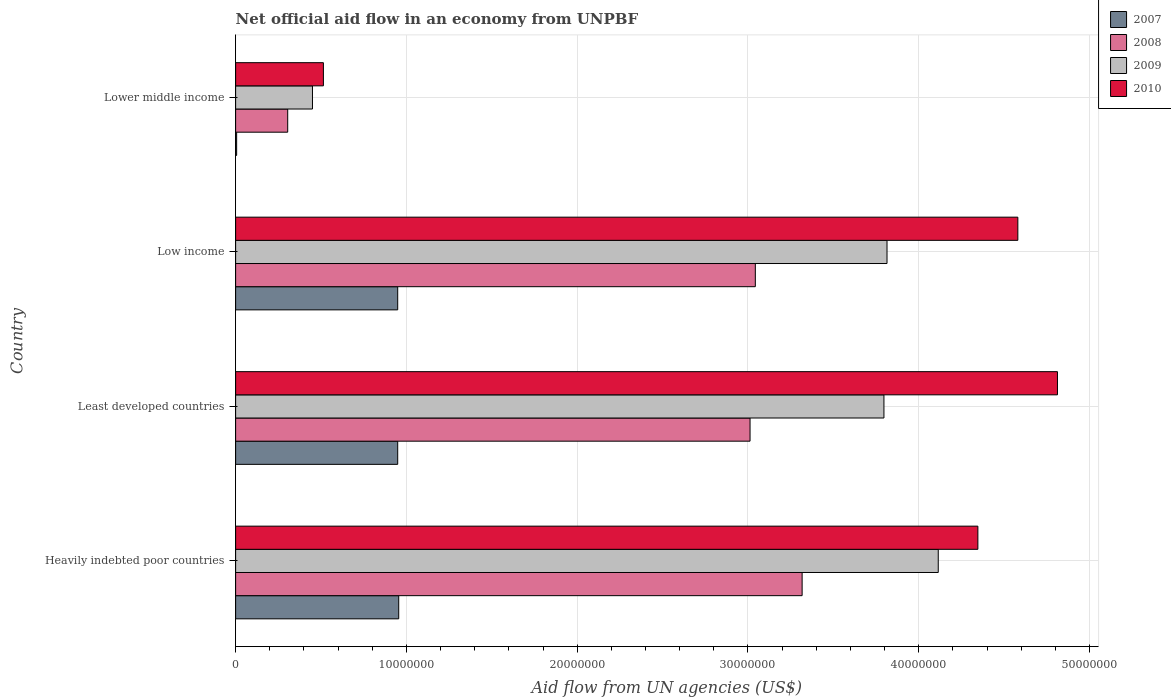How many groups of bars are there?
Keep it short and to the point. 4. Are the number of bars per tick equal to the number of legend labels?
Give a very brief answer. Yes. Are the number of bars on each tick of the Y-axis equal?
Give a very brief answer. Yes. How many bars are there on the 2nd tick from the top?
Your response must be concise. 4. How many bars are there on the 1st tick from the bottom?
Make the answer very short. 4. What is the label of the 3rd group of bars from the top?
Give a very brief answer. Least developed countries. What is the net official aid flow in 2008 in Lower middle income?
Your response must be concise. 3.05e+06. Across all countries, what is the maximum net official aid flow in 2010?
Give a very brief answer. 4.81e+07. Across all countries, what is the minimum net official aid flow in 2009?
Give a very brief answer. 4.50e+06. In which country was the net official aid flow in 2009 maximum?
Ensure brevity in your answer.  Heavily indebted poor countries. In which country was the net official aid flow in 2008 minimum?
Provide a succinct answer. Lower middle income. What is the total net official aid flow in 2010 in the graph?
Your answer should be very brief. 1.43e+08. What is the difference between the net official aid flow in 2010 in Heavily indebted poor countries and that in Lower middle income?
Your response must be concise. 3.83e+07. What is the difference between the net official aid flow in 2008 in Heavily indebted poor countries and the net official aid flow in 2009 in Lower middle income?
Your response must be concise. 2.87e+07. What is the average net official aid flow in 2008 per country?
Your answer should be very brief. 2.42e+07. What is the difference between the net official aid flow in 2007 and net official aid flow in 2010 in Least developed countries?
Offer a very short reply. -3.86e+07. What is the ratio of the net official aid flow in 2007 in Least developed countries to that in Lower middle income?
Give a very brief answer. 158.17. Is the net official aid flow in 2008 in Heavily indebted poor countries less than that in Low income?
Keep it short and to the point. No. What is the difference between the highest and the lowest net official aid flow in 2009?
Keep it short and to the point. 3.66e+07. In how many countries, is the net official aid flow in 2010 greater than the average net official aid flow in 2010 taken over all countries?
Your response must be concise. 3. How many countries are there in the graph?
Ensure brevity in your answer.  4. Does the graph contain any zero values?
Ensure brevity in your answer.  No. Does the graph contain grids?
Your response must be concise. Yes. Where does the legend appear in the graph?
Offer a very short reply. Top right. How many legend labels are there?
Make the answer very short. 4. What is the title of the graph?
Offer a terse response. Net official aid flow in an economy from UNPBF. What is the label or title of the X-axis?
Your answer should be very brief. Aid flow from UN agencies (US$). What is the Aid flow from UN agencies (US$) in 2007 in Heavily indebted poor countries?
Offer a terse response. 9.55e+06. What is the Aid flow from UN agencies (US$) of 2008 in Heavily indebted poor countries?
Ensure brevity in your answer.  3.32e+07. What is the Aid flow from UN agencies (US$) of 2009 in Heavily indebted poor countries?
Give a very brief answer. 4.11e+07. What is the Aid flow from UN agencies (US$) in 2010 in Heavily indebted poor countries?
Provide a succinct answer. 4.35e+07. What is the Aid flow from UN agencies (US$) of 2007 in Least developed countries?
Keep it short and to the point. 9.49e+06. What is the Aid flow from UN agencies (US$) of 2008 in Least developed countries?
Give a very brief answer. 3.01e+07. What is the Aid flow from UN agencies (US$) of 2009 in Least developed countries?
Provide a succinct answer. 3.80e+07. What is the Aid flow from UN agencies (US$) in 2010 in Least developed countries?
Ensure brevity in your answer.  4.81e+07. What is the Aid flow from UN agencies (US$) in 2007 in Low income?
Ensure brevity in your answer.  9.49e+06. What is the Aid flow from UN agencies (US$) of 2008 in Low income?
Give a very brief answer. 3.04e+07. What is the Aid flow from UN agencies (US$) in 2009 in Low income?
Offer a very short reply. 3.81e+07. What is the Aid flow from UN agencies (US$) of 2010 in Low income?
Provide a succinct answer. 4.58e+07. What is the Aid flow from UN agencies (US$) in 2008 in Lower middle income?
Provide a succinct answer. 3.05e+06. What is the Aid flow from UN agencies (US$) in 2009 in Lower middle income?
Keep it short and to the point. 4.50e+06. What is the Aid flow from UN agencies (US$) in 2010 in Lower middle income?
Provide a succinct answer. 5.14e+06. Across all countries, what is the maximum Aid flow from UN agencies (US$) in 2007?
Your answer should be compact. 9.55e+06. Across all countries, what is the maximum Aid flow from UN agencies (US$) in 2008?
Your response must be concise. 3.32e+07. Across all countries, what is the maximum Aid flow from UN agencies (US$) in 2009?
Make the answer very short. 4.11e+07. Across all countries, what is the maximum Aid flow from UN agencies (US$) in 2010?
Provide a succinct answer. 4.81e+07. Across all countries, what is the minimum Aid flow from UN agencies (US$) of 2008?
Your answer should be compact. 3.05e+06. Across all countries, what is the minimum Aid flow from UN agencies (US$) in 2009?
Provide a short and direct response. 4.50e+06. Across all countries, what is the minimum Aid flow from UN agencies (US$) in 2010?
Make the answer very short. 5.14e+06. What is the total Aid flow from UN agencies (US$) of 2007 in the graph?
Make the answer very short. 2.86e+07. What is the total Aid flow from UN agencies (US$) of 2008 in the graph?
Make the answer very short. 9.68e+07. What is the total Aid flow from UN agencies (US$) in 2009 in the graph?
Provide a succinct answer. 1.22e+08. What is the total Aid flow from UN agencies (US$) in 2010 in the graph?
Offer a terse response. 1.43e+08. What is the difference between the Aid flow from UN agencies (US$) of 2007 in Heavily indebted poor countries and that in Least developed countries?
Make the answer very short. 6.00e+04. What is the difference between the Aid flow from UN agencies (US$) of 2008 in Heavily indebted poor countries and that in Least developed countries?
Keep it short and to the point. 3.05e+06. What is the difference between the Aid flow from UN agencies (US$) of 2009 in Heavily indebted poor countries and that in Least developed countries?
Offer a very short reply. 3.18e+06. What is the difference between the Aid flow from UN agencies (US$) of 2010 in Heavily indebted poor countries and that in Least developed countries?
Your response must be concise. -4.66e+06. What is the difference between the Aid flow from UN agencies (US$) of 2008 in Heavily indebted poor countries and that in Low income?
Keep it short and to the point. 2.74e+06. What is the difference between the Aid flow from UN agencies (US$) of 2009 in Heavily indebted poor countries and that in Low income?
Provide a succinct answer. 3.00e+06. What is the difference between the Aid flow from UN agencies (US$) in 2010 in Heavily indebted poor countries and that in Low income?
Provide a short and direct response. -2.34e+06. What is the difference between the Aid flow from UN agencies (US$) of 2007 in Heavily indebted poor countries and that in Lower middle income?
Provide a short and direct response. 9.49e+06. What is the difference between the Aid flow from UN agencies (US$) of 2008 in Heavily indebted poor countries and that in Lower middle income?
Offer a very short reply. 3.01e+07. What is the difference between the Aid flow from UN agencies (US$) in 2009 in Heavily indebted poor countries and that in Lower middle income?
Ensure brevity in your answer.  3.66e+07. What is the difference between the Aid flow from UN agencies (US$) in 2010 in Heavily indebted poor countries and that in Lower middle income?
Provide a succinct answer. 3.83e+07. What is the difference between the Aid flow from UN agencies (US$) of 2007 in Least developed countries and that in Low income?
Provide a succinct answer. 0. What is the difference between the Aid flow from UN agencies (US$) of 2008 in Least developed countries and that in Low income?
Offer a terse response. -3.10e+05. What is the difference between the Aid flow from UN agencies (US$) of 2009 in Least developed countries and that in Low income?
Keep it short and to the point. -1.80e+05. What is the difference between the Aid flow from UN agencies (US$) of 2010 in Least developed countries and that in Low income?
Provide a short and direct response. 2.32e+06. What is the difference between the Aid flow from UN agencies (US$) in 2007 in Least developed countries and that in Lower middle income?
Offer a very short reply. 9.43e+06. What is the difference between the Aid flow from UN agencies (US$) of 2008 in Least developed countries and that in Lower middle income?
Give a very brief answer. 2.71e+07. What is the difference between the Aid flow from UN agencies (US$) in 2009 in Least developed countries and that in Lower middle income?
Your answer should be very brief. 3.35e+07. What is the difference between the Aid flow from UN agencies (US$) in 2010 in Least developed countries and that in Lower middle income?
Ensure brevity in your answer.  4.30e+07. What is the difference between the Aid flow from UN agencies (US$) in 2007 in Low income and that in Lower middle income?
Your answer should be compact. 9.43e+06. What is the difference between the Aid flow from UN agencies (US$) of 2008 in Low income and that in Lower middle income?
Offer a terse response. 2.74e+07. What is the difference between the Aid flow from UN agencies (US$) in 2009 in Low income and that in Lower middle income?
Give a very brief answer. 3.36e+07. What is the difference between the Aid flow from UN agencies (US$) of 2010 in Low income and that in Lower middle income?
Your answer should be very brief. 4.07e+07. What is the difference between the Aid flow from UN agencies (US$) of 2007 in Heavily indebted poor countries and the Aid flow from UN agencies (US$) of 2008 in Least developed countries?
Make the answer very short. -2.06e+07. What is the difference between the Aid flow from UN agencies (US$) of 2007 in Heavily indebted poor countries and the Aid flow from UN agencies (US$) of 2009 in Least developed countries?
Ensure brevity in your answer.  -2.84e+07. What is the difference between the Aid flow from UN agencies (US$) of 2007 in Heavily indebted poor countries and the Aid flow from UN agencies (US$) of 2010 in Least developed countries?
Provide a succinct answer. -3.86e+07. What is the difference between the Aid flow from UN agencies (US$) in 2008 in Heavily indebted poor countries and the Aid flow from UN agencies (US$) in 2009 in Least developed countries?
Give a very brief answer. -4.79e+06. What is the difference between the Aid flow from UN agencies (US$) in 2008 in Heavily indebted poor countries and the Aid flow from UN agencies (US$) in 2010 in Least developed countries?
Provide a short and direct response. -1.50e+07. What is the difference between the Aid flow from UN agencies (US$) in 2009 in Heavily indebted poor countries and the Aid flow from UN agencies (US$) in 2010 in Least developed countries?
Your answer should be compact. -6.98e+06. What is the difference between the Aid flow from UN agencies (US$) in 2007 in Heavily indebted poor countries and the Aid flow from UN agencies (US$) in 2008 in Low income?
Give a very brief answer. -2.09e+07. What is the difference between the Aid flow from UN agencies (US$) in 2007 in Heavily indebted poor countries and the Aid flow from UN agencies (US$) in 2009 in Low income?
Ensure brevity in your answer.  -2.86e+07. What is the difference between the Aid flow from UN agencies (US$) of 2007 in Heavily indebted poor countries and the Aid flow from UN agencies (US$) of 2010 in Low income?
Provide a short and direct response. -3.62e+07. What is the difference between the Aid flow from UN agencies (US$) in 2008 in Heavily indebted poor countries and the Aid flow from UN agencies (US$) in 2009 in Low income?
Provide a short and direct response. -4.97e+06. What is the difference between the Aid flow from UN agencies (US$) in 2008 in Heavily indebted poor countries and the Aid flow from UN agencies (US$) in 2010 in Low income?
Offer a very short reply. -1.26e+07. What is the difference between the Aid flow from UN agencies (US$) in 2009 in Heavily indebted poor countries and the Aid flow from UN agencies (US$) in 2010 in Low income?
Your answer should be compact. -4.66e+06. What is the difference between the Aid flow from UN agencies (US$) in 2007 in Heavily indebted poor countries and the Aid flow from UN agencies (US$) in 2008 in Lower middle income?
Ensure brevity in your answer.  6.50e+06. What is the difference between the Aid flow from UN agencies (US$) in 2007 in Heavily indebted poor countries and the Aid flow from UN agencies (US$) in 2009 in Lower middle income?
Provide a succinct answer. 5.05e+06. What is the difference between the Aid flow from UN agencies (US$) in 2007 in Heavily indebted poor countries and the Aid flow from UN agencies (US$) in 2010 in Lower middle income?
Provide a succinct answer. 4.41e+06. What is the difference between the Aid flow from UN agencies (US$) in 2008 in Heavily indebted poor countries and the Aid flow from UN agencies (US$) in 2009 in Lower middle income?
Offer a terse response. 2.87e+07. What is the difference between the Aid flow from UN agencies (US$) in 2008 in Heavily indebted poor countries and the Aid flow from UN agencies (US$) in 2010 in Lower middle income?
Ensure brevity in your answer.  2.80e+07. What is the difference between the Aid flow from UN agencies (US$) in 2009 in Heavily indebted poor countries and the Aid flow from UN agencies (US$) in 2010 in Lower middle income?
Your response must be concise. 3.60e+07. What is the difference between the Aid flow from UN agencies (US$) of 2007 in Least developed countries and the Aid flow from UN agencies (US$) of 2008 in Low income?
Make the answer very short. -2.09e+07. What is the difference between the Aid flow from UN agencies (US$) in 2007 in Least developed countries and the Aid flow from UN agencies (US$) in 2009 in Low income?
Ensure brevity in your answer.  -2.86e+07. What is the difference between the Aid flow from UN agencies (US$) in 2007 in Least developed countries and the Aid flow from UN agencies (US$) in 2010 in Low income?
Ensure brevity in your answer.  -3.63e+07. What is the difference between the Aid flow from UN agencies (US$) in 2008 in Least developed countries and the Aid flow from UN agencies (US$) in 2009 in Low income?
Make the answer very short. -8.02e+06. What is the difference between the Aid flow from UN agencies (US$) in 2008 in Least developed countries and the Aid flow from UN agencies (US$) in 2010 in Low income?
Offer a terse response. -1.57e+07. What is the difference between the Aid flow from UN agencies (US$) of 2009 in Least developed countries and the Aid flow from UN agencies (US$) of 2010 in Low income?
Provide a succinct answer. -7.84e+06. What is the difference between the Aid flow from UN agencies (US$) in 2007 in Least developed countries and the Aid flow from UN agencies (US$) in 2008 in Lower middle income?
Ensure brevity in your answer.  6.44e+06. What is the difference between the Aid flow from UN agencies (US$) in 2007 in Least developed countries and the Aid flow from UN agencies (US$) in 2009 in Lower middle income?
Keep it short and to the point. 4.99e+06. What is the difference between the Aid flow from UN agencies (US$) of 2007 in Least developed countries and the Aid flow from UN agencies (US$) of 2010 in Lower middle income?
Offer a very short reply. 4.35e+06. What is the difference between the Aid flow from UN agencies (US$) in 2008 in Least developed countries and the Aid flow from UN agencies (US$) in 2009 in Lower middle income?
Keep it short and to the point. 2.56e+07. What is the difference between the Aid flow from UN agencies (US$) of 2008 in Least developed countries and the Aid flow from UN agencies (US$) of 2010 in Lower middle income?
Make the answer very short. 2.50e+07. What is the difference between the Aid flow from UN agencies (US$) in 2009 in Least developed countries and the Aid flow from UN agencies (US$) in 2010 in Lower middle income?
Offer a terse response. 3.28e+07. What is the difference between the Aid flow from UN agencies (US$) in 2007 in Low income and the Aid flow from UN agencies (US$) in 2008 in Lower middle income?
Your response must be concise. 6.44e+06. What is the difference between the Aid flow from UN agencies (US$) of 2007 in Low income and the Aid flow from UN agencies (US$) of 2009 in Lower middle income?
Keep it short and to the point. 4.99e+06. What is the difference between the Aid flow from UN agencies (US$) of 2007 in Low income and the Aid flow from UN agencies (US$) of 2010 in Lower middle income?
Make the answer very short. 4.35e+06. What is the difference between the Aid flow from UN agencies (US$) in 2008 in Low income and the Aid flow from UN agencies (US$) in 2009 in Lower middle income?
Your answer should be compact. 2.59e+07. What is the difference between the Aid flow from UN agencies (US$) in 2008 in Low income and the Aid flow from UN agencies (US$) in 2010 in Lower middle income?
Provide a short and direct response. 2.53e+07. What is the difference between the Aid flow from UN agencies (US$) in 2009 in Low income and the Aid flow from UN agencies (US$) in 2010 in Lower middle income?
Your answer should be very brief. 3.30e+07. What is the average Aid flow from UN agencies (US$) of 2007 per country?
Make the answer very short. 7.15e+06. What is the average Aid flow from UN agencies (US$) in 2008 per country?
Give a very brief answer. 2.42e+07. What is the average Aid flow from UN agencies (US$) of 2009 per country?
Your answer should be compact. 3.04e+07. What is the average Aid flow from UN agencies (US$) of 2010 per country?
Provide a succinct answer. 3.56e+07. What is the difference between the Aid flow from UN agencies (US$) in 2007 and Aid flow from UN agencies (US$) in 2008 in Heavily indebted poor countries?
Make the answer very short. -2.36e+07. What is the difference between the Aid flow from UN agencies (US$) in 2007 and Aid flow from UN agencies (US$) in 2009 in Heavily indebted poor countries?
Ensure brevity in your answer.  -3.16e+07. What is the difference between the Aid flow from UN agencies (US$) in 2007 and Aid flow from UN agencies (US$) in 2010 in Heavily indebted poor countries?
Provide a succinct answer. -3.39e+07. What is the difference between the Aid flow from UN agencies (US$) in 2008 and Aid flow from UN agencies (US$) in 2009 in Heavily indebted poor countries?
Your answer should be very brief. -7.97e+06. What is the difference between the Aid flow from UN agencies (US$) in 2008 and Aid flow from UN agencies (US$) in 2010 in Heavily indebted poor countries?
Your response must be concise. -1.03e+07. What is the difference between the Aid flow from UN agencies (US$) of 2009 and Aid flow from UN agencies (US$) of 2010 in Heavily indebted poor countries?
Give a very brief answer. -2.32e+06. What is the difference between the Aid flow from UN agencies (US$) in 2007 and Aid flow from UN agencies (US$) in 2008 in Least developed countries?
Provide a succinct answer. -2.06e+07. What is the difference between the Aid flow from UN agencies (US$) of 2007 and Aid flow from UN agencies (US$) of 2009 in Least developed countries?
Give a very brief answer. -2.85e+07. What is the difference between the Aid flow from UN agencies (US$) of 2007 and Aid flow from UN agencies (US$) of 2010 in Least developed countries?
Your answer should be very brief. -3.86e+07. What is the difference between the Aid flow from UN agencies (US$) of 2008 and Aid flow from UN agencies (US$) of 2009 in Least developed countries?
Offer a very short reply. -7.84e+06. What is the difference between the Aid flow from UN agencies (US$) in 2008 and Aid flow from UN agencies (US$) in 2010 in Least developed countries?
Provide a short and direct response. -1.80e+07. What is the difference between the Aid flow from UN agencies (US$) in 2009 and Aid flow from UN agencies (US$) in 2010 in Least developed countries?
Offer a terse response. -1.02e+07. What is the difference between the Aid flow from UN agencies (US$) in 2007 and Aid flow from UN agencies (US$) in 2008 in Low income?
Keep it short and to the point. -2.09e+07. What is the difference between the Aid flow from UN agencies (US$) of 2007 and Aid flow from UN agencies (US$) of 2009 in Low income?
Give a very brief answer. -2.86e+07. What is the difference between the Aid flow from UN agencies (US$) of 2007 and Aid flow from UN agencies (US$) of 2010 in Low income?
Give a very brief answer. -3.63e+07. What is the difference between the Aid flow from UN agencies (US$) of 2008 and Aid flow from UN agencies (US$) of 2009 in Low income?
Provide a short and direct response. -7.71e+06. What is the difference between the Aid flow from UN agencies (US$) in 2008 and Aid flow from UN agencies (US$) in 2010 in Low income?
Ensure brevity in your answer.  -1.54e+07. What is the difference between the Aid flow from UN agencies (US$) in 2009 and Aid flow from UN agencies (US$) in 2010 in Low income?
Make the answer very short. -7.66e+06. What is the difference between the Aid flow from UN agencies (US$) of 2007 and Aid flow from UN agencies (US$) of 2008 in Lower middle income?
Make the answer very short. -2.99e+06. What is the difference between the Aid flow from UN agencies (US$) in 2007 and Aid flow from UN agencies (US$) in 2009 in Lower middle income?
Offer a very short reply. -4.44e+06. What is the difference between the Aid flow from UN agencies (US$) of 2007 and Aid flow from UN agencies (US$) of 2010 in Lower middle income?
Provide a short and direct response. -5.08e+06. What is the difference between the Aid flow from UN agencies (US$) in 2008 and Aid flow from UN agencies (US$) in 2009 in Lower middle income?
Provide a succinct answer. -1.45e+06. What is the difference between the Aid flow from UN agencies (US$) in 2008 and Aid flow from UN agencies (US$) in 2010 in Lower middle income?
Your answer should be very brief. -2.09e+06. What is the difference between the Aid flow from UN agencies (US$) of 2009 and Aid flow from UN agencies (US$) of 2010 in Lower middle income?
Your answer should be very brief. -6.40e+05. What is the ratio of the Aid flow from UN agencies (US$) in 2007 in Heavily indebted poor countries to that in Least developed countries?
Offer a very short reply. 1.01. What is the ratio of the Aid flow from UN agencies (US$) of 2008 in Heavily indebted poor countries to that in Least developed countries?
Offer a very short reply. 1.1. What is the ratio of the Aid flow from UN agencies (US$) of 2009 in Heavily indebted poor countries to that in Least developed countries?
Your response must be concise. 1.08. What is the ratio of the Aid flow from UN agencies (US$) of 2010 in Heavily indebted poor countries to that in Least developed countries?
Offer a terse response. 0.9. What is the ratio of the Aid flow from UN agencies (US$) of 2008 in Heavily indebted poor countries to that in Low income?
Your response must be concise. 1.09. What is the ratio of the Aid flow from UN agencies (US$) in 2009 in Heavily indebted poor countries to that in Low income?
Give a very brief answer. 1.08. What is the ratio of the Aid flow from UN agencies (US$) in 2010 in Heavily indebted poor countries to that in Low income?
Offer a very short reply. 0.95. What is the ratio of the Aid flow from UN agencies (US$) in 2007 in Heavily indebted poor countries to that in Lower middle income?
Your response must be concise. 159.17. What is the ratio of the Aid flow from UN agencies (US$) of 2008 in Heavily indebted poor countries to that in Lower middle income?
Offer a very short reply. 10.88. What is the ratio of the Aid flow from UN agencies (US$) in 2009 in Heavily indebted poor countries to that in Lower middle income?
Keep it short and to the point. 9.14. What is the ratio of the Aid flow from UN agencies (US$) in 2010 in Heavily indebted poor countries to that in Lower middle income?
Provide a short and direct response. 8.46. What is the ratio of the Aid flow from UN agencies (US$) in 2007 in Least developed countries to that in Low income?
Offer a very short reply. 1. What is the ratio of the Aid flow from UN agencies (US$) in 2009 in Least developed countries to that in Low income?
Your answer should be compact. 1. What is the ratio of the Aid flow from UN agencies (US$) in 2010 in Least developed countries to that in Low income?
Your answer should be compact. 1.05. What is the ratio of the Aid flow from UN agencies (US$) in 2007 in Least developed countries to that in Lower middle income?
Keep it short and to the point. 158.17. What is the ratio of the Aid flow from UN agencies (US$) in 2008 in Least developed countries to that in Lower middle income?
Give a very brief answer. 9.88. What is the ratio of the Aid flow from UN agencies (US$) in 2009 in Least developed countries to that in Lower middle income?
Your response must be concise. 8.44. What is the ratio of the Aid flow from UN agencies (US$) of 2010 in Least developed countries to that in Lower middle income?
Provide a short and direct response. 9.36. What is the ratio of the Aid flow from UN agencies (US$) in 2007 in Low income to that in Lower middle income?
Offer a terse response. 158.17. What is the ratio of the Aid flow from UN agencies (US$) in 2008 in Low income to that in Lower middle income?
Ensure brevity in your answer.  9.98. What is the ratio of the Aid flow from UN agencies (US$) in 2009 in Low income to that in Lower middle income?
Provide a succinct answer. 8.48. What is the ratio of the Aid flow from UN agencies (US$) in 2010 in Low income to that in Lower middle income?
Give a very brief answer. 8.91. What is the difference between the highest and the second highest Aid flow from UN agencies (US$) in 2007?
Ensure brevity in your answer.  6.00e+04. What is the difference between the highest and the second highest Aid flow from UN agencies (US$) in 2008?
Give a very brief answer. 2.74e+06. What is the difference between the highest and the second highest Aid flow from UN agencies (US$) of 2010?
Keep it short and to the point. 2.32e+06. What is the difference between the highest and the lowest Aid flow from UN agencies (US$) in 2007?
Your response must be concise. 9.49e+06. What is the difference between the highest and the lowest Aid flow from UN agencies (US$) in 2008?
Offer a very short reply. 3.01e+07. What is the difference between the highest and the lowest Aid flow from UN agencies (US$) in 2009?
Give a very brief answer. 3.66e+07. What is the difference between the highest and the lowest Aid flow from UN agencies (US$) in 2010?
Provide a short and direct response. 4.30e+07. 